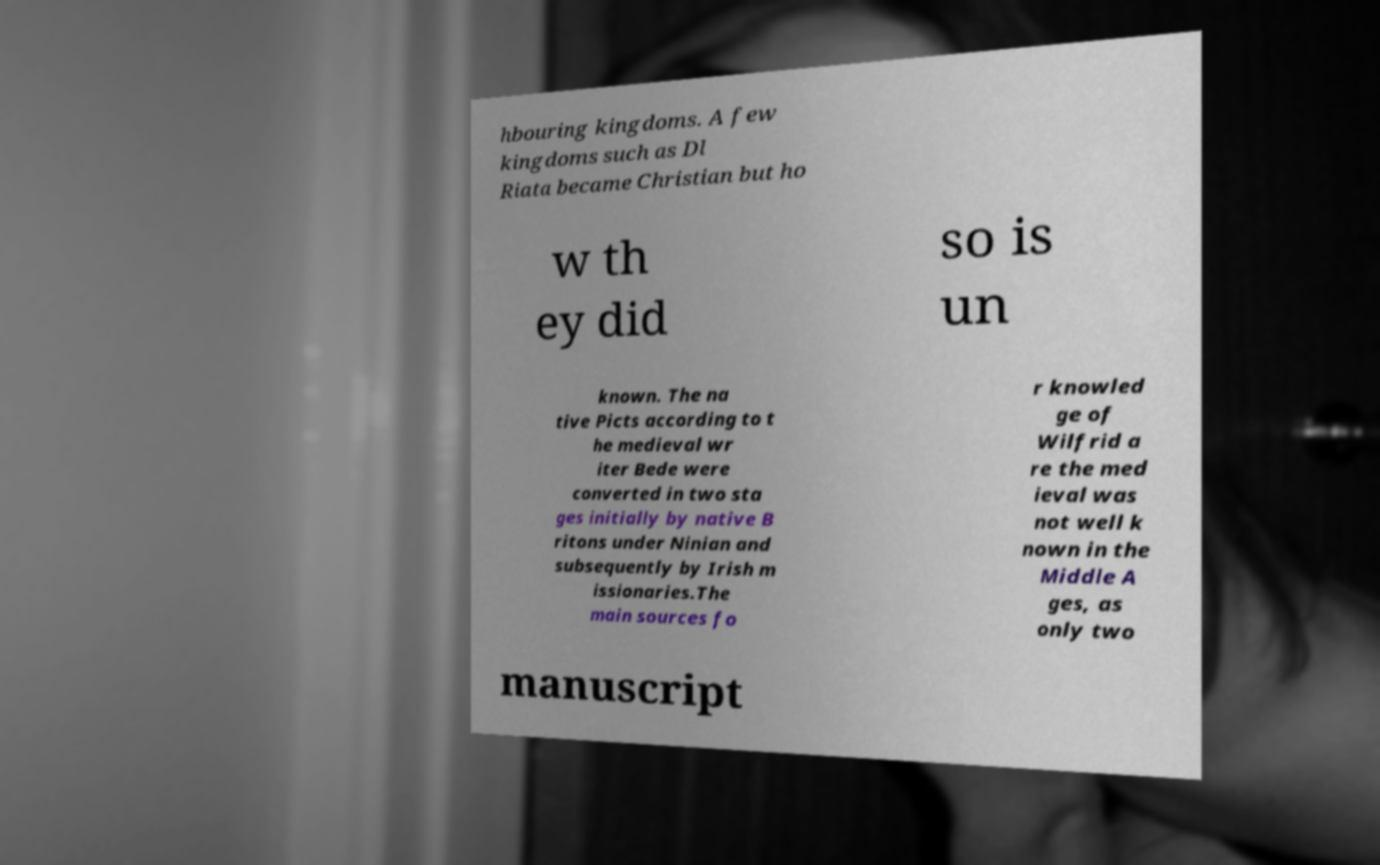Could you extract and type out the text from this image? hbouring kingdoms. A few kingdoms such as Dl Riata became Christian but ho w th ey did so is un known. The na tive Picts according to t he medieval wr iter Bede were converted in two sta ges initially by native B ritons under Ninian and subsequently by Irish m issionaries.The main sources fo r knowled ge of Wilfrid a re the med ieval was not well k nown in the Middle A ges, as only two manuscript 